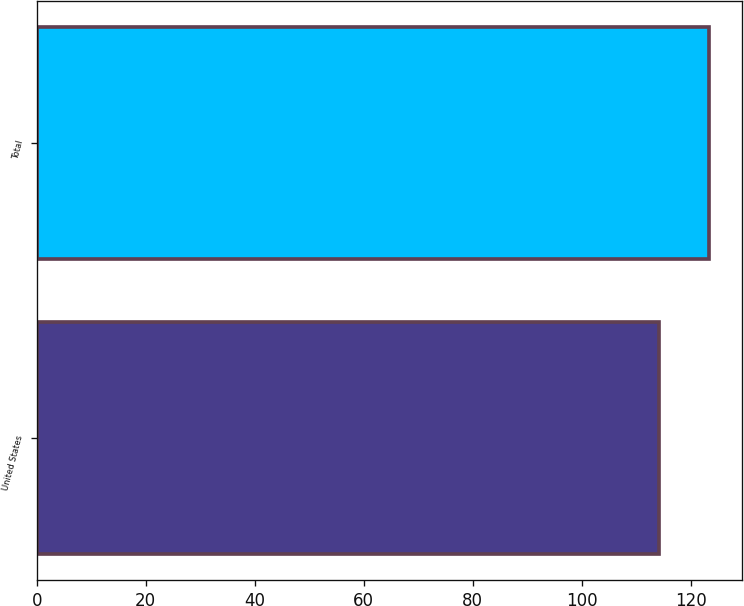<chart> <loc_0><loc_0><loc_500><loc_500><bar_chart><fcel>United States<fcel>Total<nl><fcel>114.2<fcel>123.3<nl></chart> 